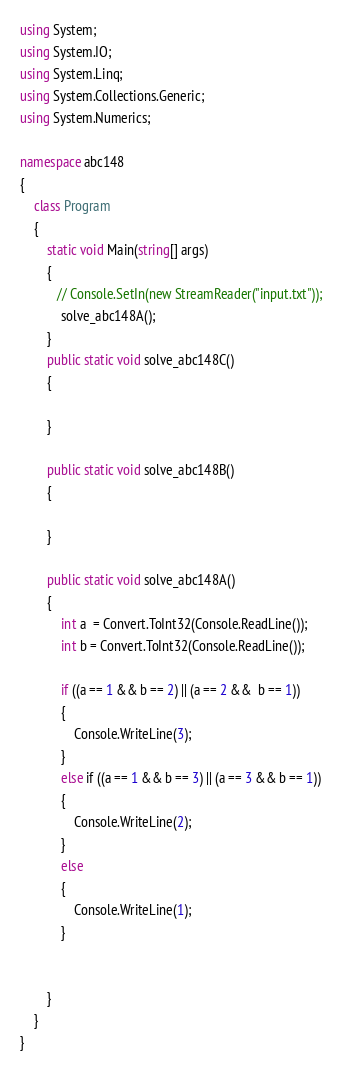Convert code to text. <code><loc_0><loc_0><loc_500><loc_500><_C#_>using System;
using System.IO;
using System.Linq;
using System.Collections.Generic;
using System.Numerics;

namespace abc148
{
    class Program
    {
        static void Main(string[] args)
        {
           // Console.SetIn(new StreamReader("input.txt"));
            solve_abc148A();
        }
        public static void solve_abc148C()
        {

        }

        public static void solve_abc148B()
        {

        }

        public static void solve_abc148A()
        {
            int a  = Convert.ToInt32(Console.ReadLine());
            int b = Convert.ToInt32(Console.ReadLine());

            if ((a == 1 && b == 2) || (a == 2 &&  b == 1))
            {
                Console.WriteLine(3);
            }
            else if ((a == 1 && b == 3) || (a == 3 && b == 1))
            {
                Console.WriteLine(2);
            }
            else
            {
                Console.WriteLine(1);
            }


        }
    }
}
</code> 